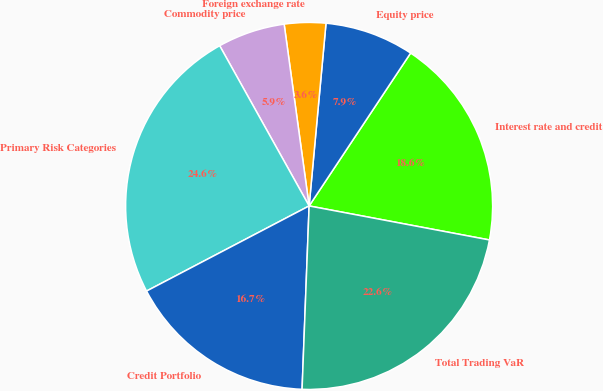Convert chart to OTSL. <chart><loc_0><loc_0><loc_500><loc_500><pie_chart><fcel>Interest rate and credit<fcel>Equity price<fcel>Foreign exchange rate<fcel>Commodity price<fcel>Primary Risk Categories<fcel>Credit Portfolio<fcel>Total Trading VaR<nl><fcel>18.64%<fcel>7.86%<fcel>3.64%<fcel>5.93%<fcel>24.57%<fcel>16.71%<fcel>22.64%<nl></chart> 